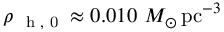Convert formula to latex. <formula><loc_0><loc_0><loc_500><loc_500>\rho _ { h , 0 } \approx 0 . 0 1 0 M _ { \odot } \, p c ^ { - 3 }</formula> 